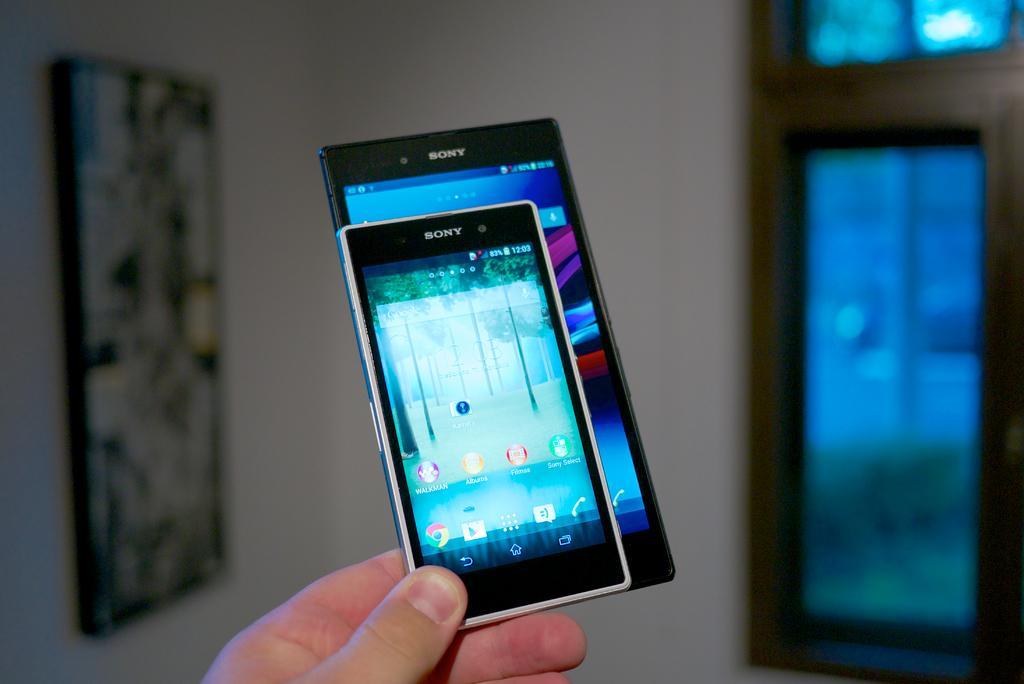<image>
Render a clear and concise summary of the photo. A person holding two Sony cell phones up against each other and one being larger that the other. 